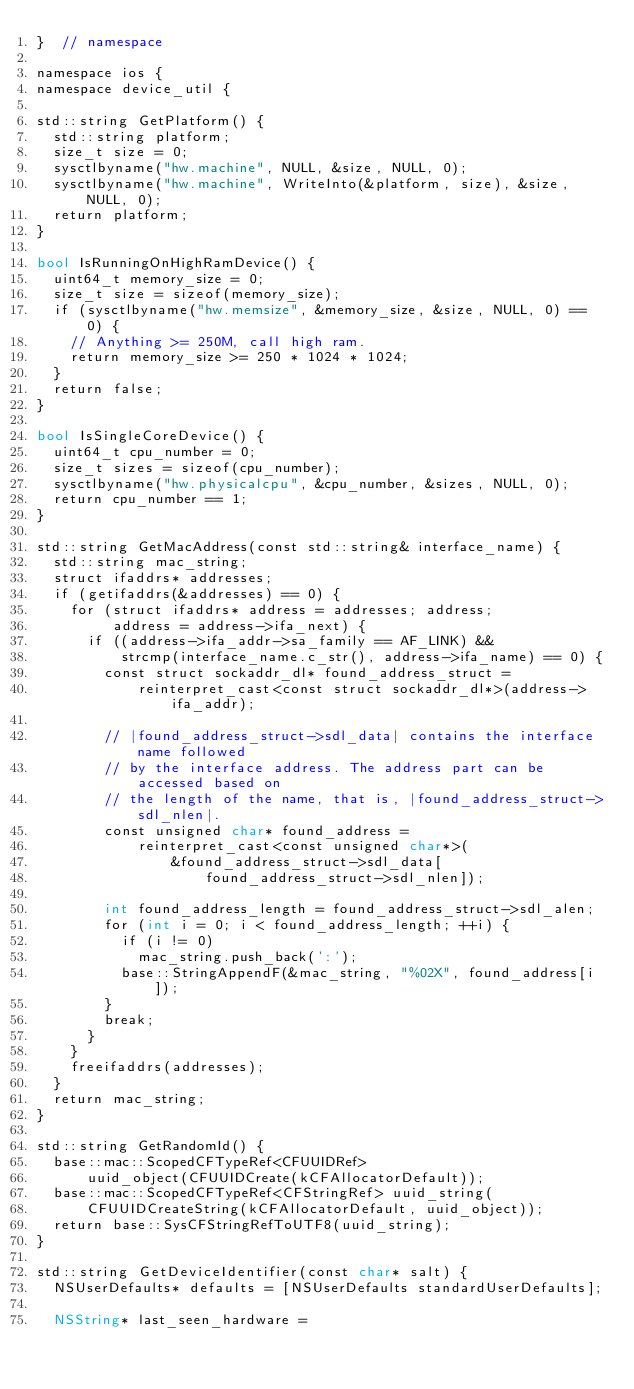Convert code to text. <code><loc_0><loc_0><loc_500><loc_500><_ObjectiveC_>}  // namespace

namespace ios {
namespace device_util {

std::string GetPlatform() {
  std::string platform;
  size_t size = 0;
  sysctlbyname("hw.machine", NULL, &size, NULL, 0);
  sysctlbyname("hw.machine", WriteInto(&platform, size), &size, NULL, 0);
  return platform;
}

bool IsRunningOnHighRamDevice() {
  uint64_t memory_size = 0;
  size_t size = sizeof(memory_size);
  if (sysctlbyname("hw.memsize", &memory_size, &size, NULL, 0) == 0) {
    // Anything >= 250M, call high ram.
    return memory_size >= 250 * 1024 * 1024;
  }
  return false;
}

bool IsSingleCoreDevice() {
  uint64_t cpu_number = 0;
  size_t sizes = sizeof(cpu_number);
  sysctlbyname("hw.physicalcpu", &cpu_number, &sizes, NULL, 0);
  return cpu_number == 1;
}

std::string GetMacAddress(const std::string& interface_name) {
  std::string mac_string;
  struct ifaddrs* addresses;
  if (getifaddrs(&addresses) == 0) {
    for (struct ifaddrs* address = addresses; address;
         address = address->ifa_next) {
      if ((address->ifa_addr->sa_family == AF_LINK) &&
          strcmp(interface_name.c_str(), address->ifa_name) == 0) {
        const struct sockaddr_dl* found_address_struct =
            reinterpret_cast<const struct sockaddr_dl*>(address->ifa_addr);

        // |found_address_struct->sdl_data| contains the interface name followed
        // by the interface address. The address part can be accessed based on
        // the length of the name, that is, |found_address_struct->sdl_nlen|.
        const unsigned char* found_address =
            reinterpret_cast<const unsigned char*>(
                &found_address_struct->sdl_data[
                    found_address_struct->sdl_nlen]);

        int found_address_length = found_address_struct->sdl_alen;
        for (int i = 0; i < found_address_length; ++i) {
          if (i != 0)
            mac_string.push_back(':');
          base::StringAppendF(&mac_string, "%02X", found_address[i]);
        }
        break;
      }
    }
    freeifaddrs(addresses);
  }
  return mac_string;
}

std::string GetRandomId() {
  base::mac::ScopedCFTypeRef<CFUUIDRef>
      uuid_object(CFUUIDCreate(kCFAllocatorDefault));
  base::mac::ScopedCFTypeRef<CFStringRef> uuid_string(
      CFUUIDCreateString(kCFAllocatorDefault, uuid_object));
  return base::SysCFStringRefToUTF8(uuid_string);
}

std::string GetDeviceIdentifier(const char* salt) {
  NSUserDefaults* defaults = [NSUserDefaults standardUserDefaults];

  NSString* last_seen_hardware =</code> 